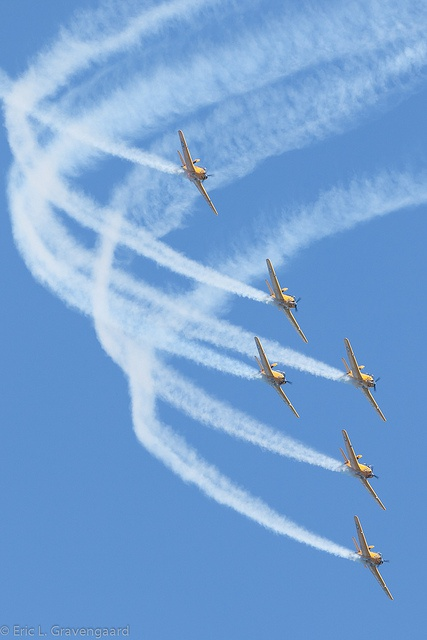Describe the objects in this image and their specific colors. I can see airplane in gray tones, airplane in gray tones, airplane in gray tones, airplane in gray and tan tones, and airplane in gray tones in this image. 